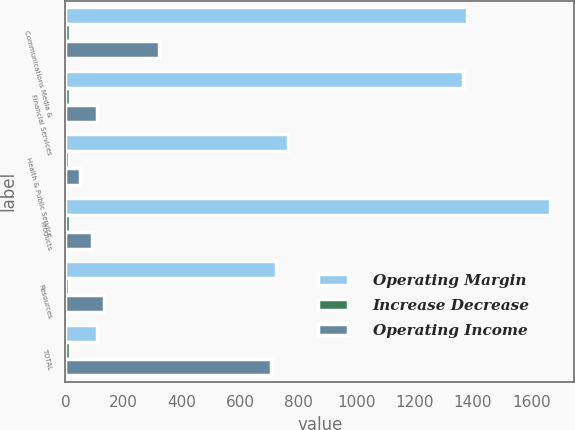Convert chart. <chart><loc_0><loc_0><loc_500><loc_500><stacked_bar_chart><ecel><fcel>Communications Media &<fcel>Financial Services<fcel>Health & Public Service<fcel>Products<fcel>Resources<fcel>TOTAL<nl><fcel>Operating Margin<fcel>1380<fcel>1365<fcel>766<fcel>1664<fcel>724<fcel>109<nl><fcel>Increase Decrease<fcel>17<fcel>16<fcel>11<fcel>15<fcel>12<fcel>14.4<nl><fcel>Operating Income<fcel>323<fcel>109<fcel>51<fcel>90<fcel>134<fcel>707<nl></chart> 